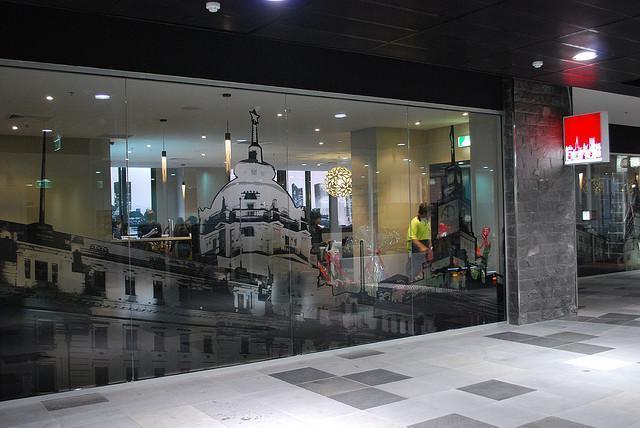How many panes of glass are in this store front?
Give a very brief answer. 1. 